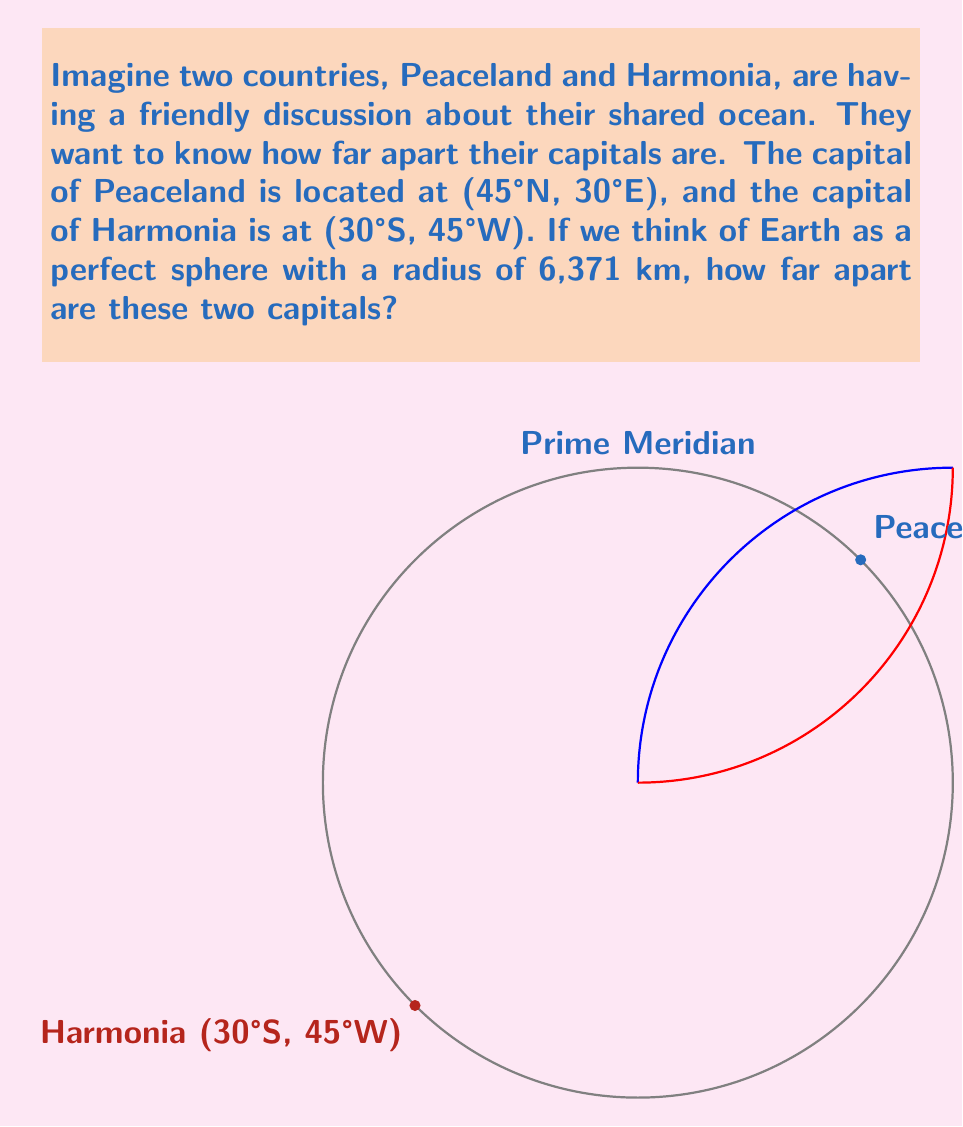Can you solve this math problem? Let's solve this step-by-step:

1) First, we need to convert the coordinates to radians:
   Peaceland: $\phi_1 = 45° \cdot \frac{\pi}{180} = \frac{\pi}{4}$, $\lambda_1 = 30° \cdot \frac{\pi}{180} = \frac{\pi}{6}$
   Harmonia: $\phi_2 = -30° \cdot \frac{\pi}{180} = -\frac{\pi}{6}$, $\lambda_2 = -45° \cdot \frac{\pi}{180} = -\frac{\pi}{4}$

2) We can use the spherical law of cosines to find the central angle $\Delta \sigma$ between the two points:

   $$\cos(\Delta \sigma) = \sin(\phi_1)\sin(\phi_2) + \cos(\phi_1)\cos(\phi_2)\cos(\Delta \lambda)$$

   where $\Delta \lambda = |\lambda_1 - \lambda_2|$

3) Let's calculate $\Delta \lambda$:
   $$\Delta \lambda = |\frac{\pi}{6} - (-\frac{\pi}{4})| = |\frac{\pi}{6} + \frac{\pi}{4}| = \frac{5\pi}{12}$$

4) Now we can substitute all values into the formula:

   $$\cos(\Delta \sigma) = \sin(\frac{\pi}{4})\sin(-\frac{\pi}{6}) + \cos(\frac{\pi}{4})\cos(-\frac{\pi}{6})\cos(\frac{5\pi}{12})$$

5) Calculating this (you can use a calculator):
   $$\cos(\Delta \sigma) \approx 0.2590$$

6) Taking the inverse cosine:
   $$\Delta \sigma \approx 1.3052 \text{ radians}$$

7) The distance $d$ along the great circle is then:
   $$d = R \cdot \Delta \sigma$$
   where $R$ is the radius of the Earth.

8) Substituting $R = 6371$ km:
   $$d = 6371 \cdot 1.3052 \approx 8315.4 \text{ km}$$
Answer: $8315.4 \text{ km}$ 